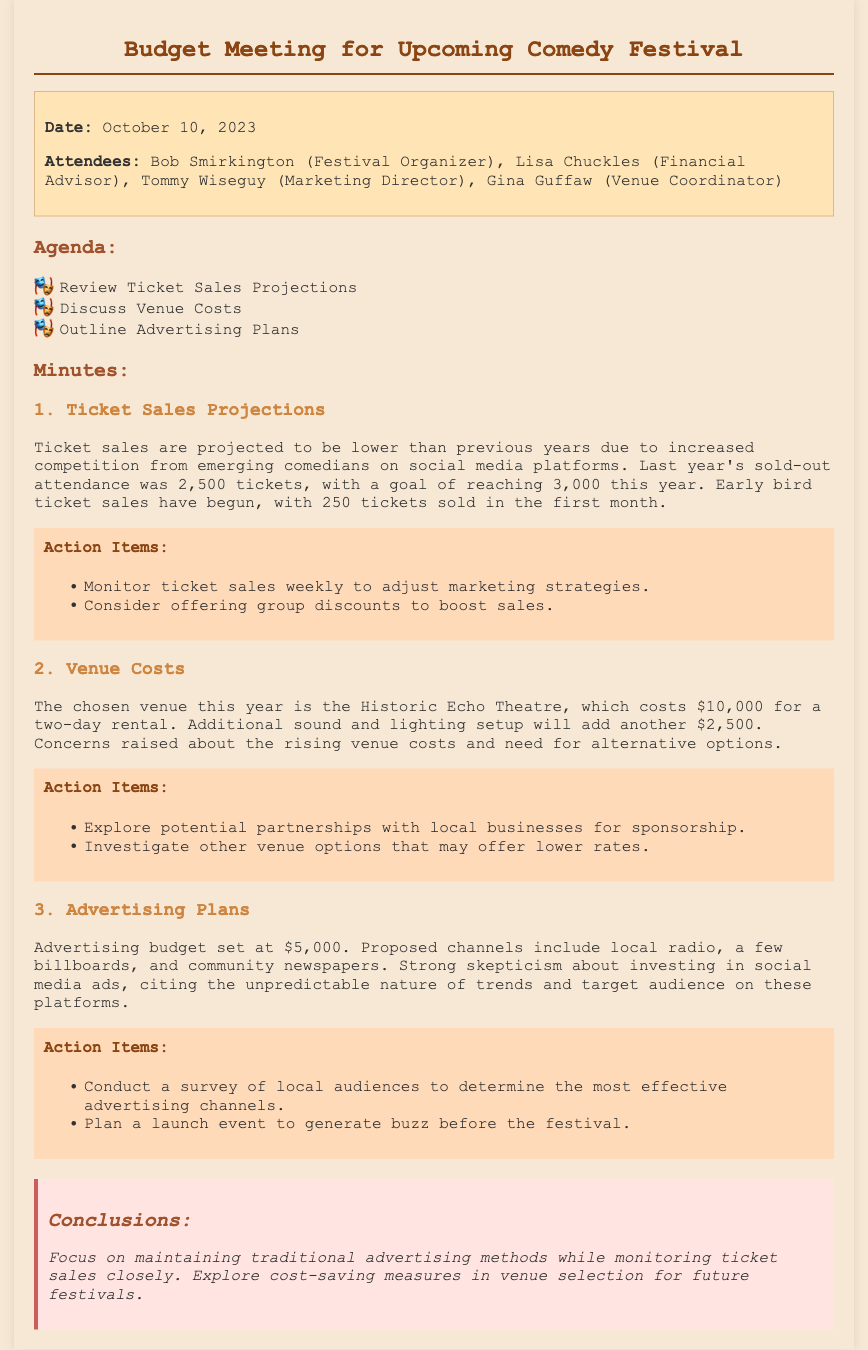What is the date of the meeting? The date of the meeting is mentioned in the info section at the top of the document.
Answer: October 10, 2023 Who is the Financial Advisor? The Financial Advisor's name is listed among the attendees.
Answer: Lisa Chuckles How many tickets were sold in the first month? The number of tickets sold in the first month is specified under the ticket sales projections section.
Answer: 250 What is the cost of the venue rental? The cost of the venue rental can be found in the venue costs section of the document.
Answer: $10,000 What is the allocated budget for advertising? The advertising budget is stated clearly in the advertising plans section.
Answer: $5,000 What concerns were raised about advertising? Concerns regarding advertising are discussed under the advertising plans section.
Answer: Skepticism about social media ads How many action items are listed under Venue Costs? The number of action items can be counted in the action items section for Venue Costs.
Answer: 2 What is the goal for ticket sales this year? The goal for ticket sales is noted in the ticket sales projections section.
Answer: 3,000 What is the additional cost for sound and lighting? The additional cost for sound and lighting is given in the venue costs section.
Answer: $2,500 